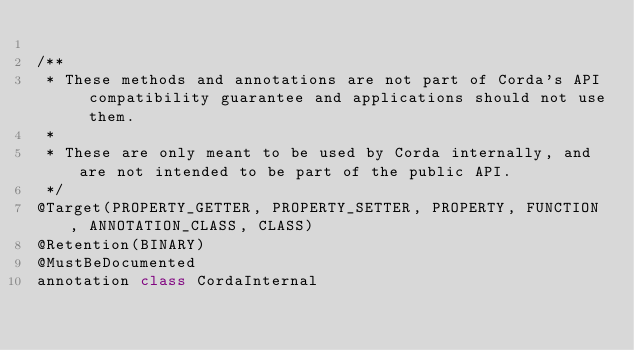<code> <loc_0><loc_0><loc_500><loc_500><_Kotlin_>
/**
 * These methods and annotations are not part of Corda's API compatibility guarantee and applications should not use them.
 *
 * These are only meant to be used by Corda internally, and are not intended to be part of the public API.
 */
@Target(PROPERTY_GETTER, PROPERTY_SETTER, PROPERTY, FUNCTION, ANNOTATION_CLASS, CLASS)
@Retention(BINARY)
@MustBeDocumented
annotation class CordaInternal</code> 